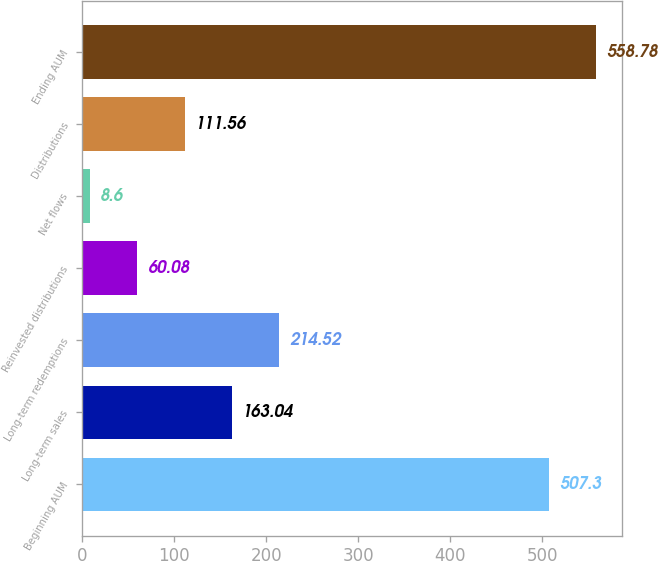Convert chart. <chart><loc_0><loc_0><loc_500><loc_500><bar_chart><fcel>Beginning AUM<fcel>Long-term sales<fcel>Long-term redemptions<fcel>Reinvested distributions<fcel>Net flows<fcel>Distributions<fcel>Ending AUM<nl><fcel>507.3<fcel>163.04<fcel>214.52<fcel>60.08<fcel>8.6<fcel>111.56<fcel>558.78<nl></chart> 